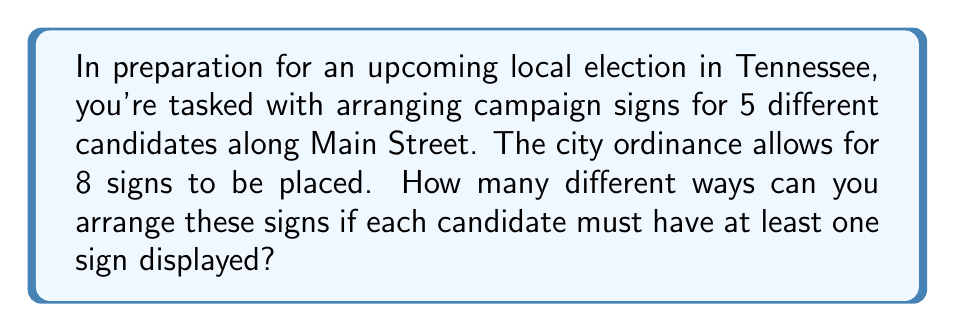Teach me how to tackle this problem. Let's approach this step-by-step using the stars and bars method:

1) First, we need to distribute 3 extra signs (8 total - 5 minimum) among the 5 candidates.

2) This is equivalent to finding the number of ways to put 3 identical objects into 5 distinct boxes, which is a classic stars and bars problem.

3) The formula for this is:

   $$\binom{n+k-1}{k}$$

   where $n$ is the number of boxes (candidates) and $k$ is the number of objects (extra signs).

4) In this case, $n = 5$ and $k = 3$, so we have:

   $$\binom{5+3-1}{3} = \binom{7}{3}$$

5) We can calculate this as:

   $$\binom{7}{3} = \frac{7!}{3!(7-3)!} = \frac{7 \cdot 6 \cdot 5}{3 \cdot 2 \cdot 1} = 35$$

6) Now, for each of these 35 distributions of extra signs, we need to arrange the 8 total signs.

7) This is a straightforward permutation of 8 objects, which is simply 8!.

8) Therefore, the total number of arrangements is:

   $$35 \cdot 8! = 35 \cdot 40,320 = 1,411,200$$
Answer: 1,411,200 